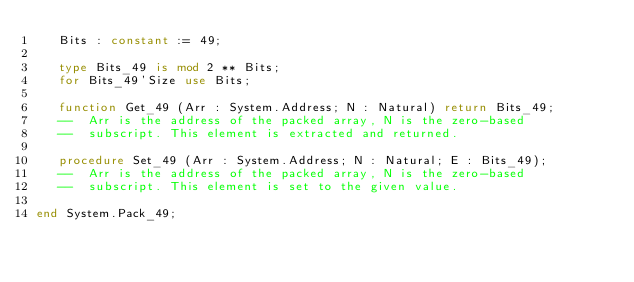Convert code to text. <code><loc_0><loc_0><loc_500><loc_500><_Ada_>   Bits : constant := 49;

   type Bits_49 is mod 2 ** Bits;
   for Bits_49'Size use Bits;

   function Get_49 (Arr : System.Address; N : Natural) return Bits_49;
   --  Arr is the address of the packed array, N is the zero-based
   --  subscript. This element is extracted and returned.

   procedure Set_49 (Arr : System.Address; N : Natural; E : Bits_49);
   --  Arr is the address of the packed array, N is the zero-based
   --  subscript. This element is set to the given value.

end System.Pack_49;
</code> 